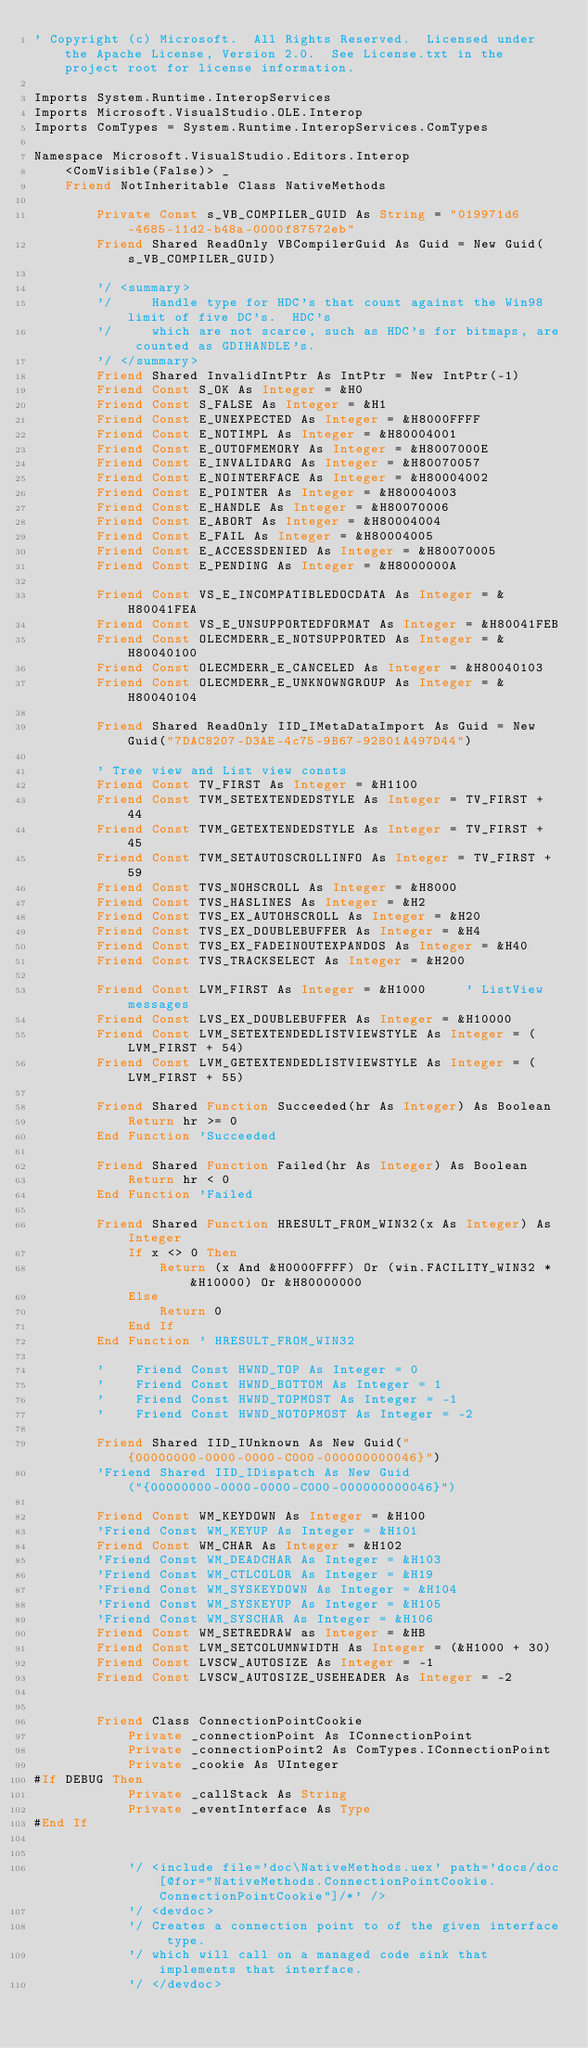Convert code to text. <code><loc_0><loc_0><loc_500><loc_500><_VisualBasic_>' Copyright (c) Microsoft.  All Rights Reserved.  Licensed under the Apache License, Version 2.0.  See License.txt in the project root for license information.

Imports System.Runtime.InteropServices
Imports Microsoft.VisualStudio.OLE.Interop
Imports ComTypes = System.Runtime.InteropServices.ComTypes

Namespace Microsoft.VisualStudio.Editors.Interop
    <ComVisible(False)> _
    Friend NotInheritable Class NativeMethods

        Private Const s_VB_COMPILER_GUID As String = "019971d6-4685-11d2-b48a-0000f87572eb"
        Friend Shared ReadOnly VBCompilerGuid As Guid = New Guid(s_VB_COMPILER_GUID)

        '/ <summary>
        '/     Handle type for HDC's that count against the Win98 limit of five DC's.  HDC's
        '/     which are not scarce, such as HDC's for bitmaps, are counted as GDIHANDLE's.
        '/ </summary>
        Friend Shared InvalidIntPtr As IntPtr = New IntPtr(-1)
        Friend Const S_OK As Integer = &H0
        Friend Const S_FALSE As Integer = &H1
        Friend Const E_UNEXPECTED As Integer = &H8000FFFF
        Friend Const E_NOTIMPL As Integer = &H80004001
        Friend Const E_OUTOFMEMORY As Integer = &H8007000E
        Friend Const E_INVALIDARG As Integer = &H80070057
        Friend Const E_NOINTERFACE As Integer = &H80004002
        Friend Const E_POINTER As Integer = &H80004003
        Friend Const E_HANDLE As Integer = &H80070006
        Friend Const E_ABORT As Integer = &H80004004
        Friend Const E_FAIL As Integer = &H80004005
        Friend Const E_ACCESSDENIED As Integer = &H80070005
        Friend Const E_PENDING As Integer = &H8000000A

        Friend Const VS_E_INCOMPATIBLEDOCDATA As Integer = &H80041FEA
        Friend Const VS_E_UNSUPPORTEDFORMAT As Integer = &H80041FEB
        Friend Const OLECMDERR_E_NOTSUPPORTED As Integer = &H80040100
        Friend Const OLECMDERR_E_CANCELED As Integer = &H80040103
        Friend Const OLECMDERR_E_UNKNOWNGROUP As Integer = &H80040104

        Friend Shared ReadOnly IID_IMetaDataImport As Guid = New Guid("7DAC8207-D3AE-4c75-9B67-92801A497D44")

        ' Tree view and List view consts
        Friend Const TV_FIRST As Integer = &H1100
        Friend Const TVM_SETEXTENDEDSTYLE As Integer = TV_FIRST + 44
        Friend Const TVM_GETEXTENDEDSTYLE As Integer = TV_FIRST + 45
        Friend Const TVM_SETAUTOSCROLLINFO As Integer = TV_FIRST + 59
        Friend Const TVS_NOHSCROLL As Integer = &H8000
        Friend Const TVS_HASLINES As Integer = &H2
        Friend Const TVS_EX_AUTOHSCROLL As Integer = &H20
        Friend Const TVS_EX_DOUBLEBUFFER As Integer = &H4
        Friend Const TVS_EX_FADEINOUTEXPANDOS As Integer = &H40
        Friend Const TVS_TRACKSELECT As Integer = &H200

        Friend Const LVM_FIRST As Integer = &H1000     ' ListView messages
        Friend Const LVS_EX_DOUBLEBUFFER As Integer = &H10000
        Friend Const LVM_SETEXTENDEDLISTVIEWSTYLE As Integer = (LVM_FIRST + 54)
        Friend Const LVM_GETEXTENDEDLISTVIEWSTYLE As Integer = (LVM_FIRST + 55)

        Friend Shared Function Succeeded(hr As Integer) As Boolean
            Return hr >= 0
        End Function 'Succeeded

        Friend Shared Function Failed(hr As Integer) As Boolean
            Return hr < 0
        End Function 'Failed

        Friend Shared Function HRESULT_FROM_WIN32(x As Integer) As Integer
            If x <> 0 Then
                Return (x And &H0000FFFF) Or (win.FACILITY_WIN32 * &H10000) Or &H80000000
            Else
                Return 0
            End If
        End Function ' HRESULT_FROM_WIN32

        '    Friend Const HWND_TOP As Integer = 0
        '    Friend Const HWND_BOTTOM As Integer = 1
        '    Friend Const HWND_TOPMOST As Integer = -1
        '    Friend Const HWND_NOTOPMOST As Integer = -2

        Friend Shared IID_IUnknown As New Guid("{00000000-0000-0000-C000-000000000046}")
        'Friend Shared IID_IDispatch As New Guid("{00000000-0000-0000-C000-000000000046}")

        Friend Const WM_KEYDOWN As Integer = &H100
        'Friend Const WM_KEYUP As Integer = &H101
        Friend Const WM_CHAR As Integer = &H102
        'Friend Const WM_DEADCHAR As Integer = &H103
        'Friend Const WM_CTLCOLOR As Integer = &H19
        'Friend Const WM_SYSKEYDOWN As Integer = &H104
        'Friend Const WM_SYSKEYUP As Integer = &H105
        'Friend Const WM_SYSCHAR As Integer = &H106
        Friend Const WM_SETREDRAW as Integer = &HB
        Friend Const LVM_SETCOLUMNWIDTH As Integer = (&H1000 + 30)
        Friend Const LVSCW_AUTOSIZE As Integer = -1
        Friend Const LVSCW_AUTOSIZE_USEHEADER As Integer = -2


        Friend Class ConnectionPointCookie
            Private _connectionPoint As IConnectionPoint
            Private _connectionPoint2 As ComTypes.IConnectionPoint
            Private _cookie As UInteger
#If DEBUG Then
            Private _callStack As String
            Private _eventInterface As Type
#End If


            '/ <include file='doc\NativeMethods.uex' path='docs/doc[@for="NativeMethods.ConnectionPointCookie.ConnectionPointCookie"]/*' />
            '/ <devdoc>
            '/ Creates a connection point to of the given interface type.
            '/ which will call on a managed code sink that implements that interface.
            '/ </devdoc></code> 